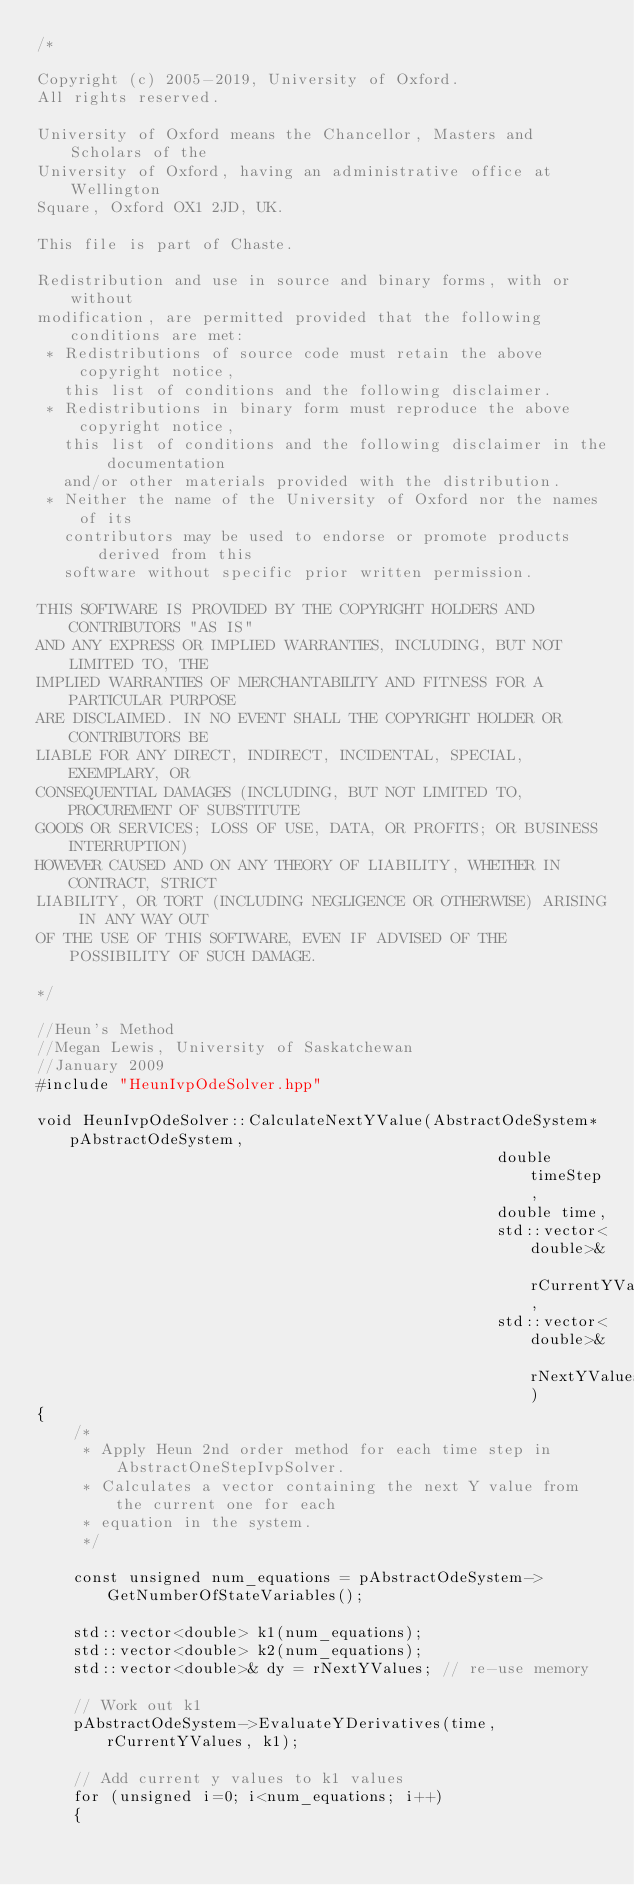<code> <loc_0><loc_0><loc_500><loc_500><_C++_>/*

Copyright (c) 2005-2019, University of Oxford.
All rights reserved.

University of Oxford means the Chancellor, Masters and Scholars of the
University of Oxford, having an administrative office at Wellington
Square, Oxford OX1 2JD, UK.

This file is part of Chaste.

Redistribution and use in source and binary forms, with or without
modification, are permitted provided that the following conditions are met:
 * Redistributions of source code must retain the above copyright notice,
   this list of conditions and the following disclaimer.
 * Redistributions in binary form must reproduce the above copyright notice,
   this list of conditions and the following disclaimer in the documentation
   and/or other materials provided with the distribution.
 * Neither the name of the University of Oxford nor the names of its
   contributors may be used to endorse or promote products derived from this
   software without specific prior written permission.

THIS SOFTWARE IS PROVIDED BY THE COPYRIGHT HOLDERS AND CONTRIBUTORS "AS IS"
AND ANY EXPRESS OR IMPLIED WARRANTIES, INCLUDING, BUT NOT LIMITED TO, THE
IMPLIED WARRANTIES OF MERCHANTABILITY AND FITNESS FOR A PARTICULAR PURPOSE
ARE DISCLAIMED. IN NO EVENT SHALL THE COPYRIGHT HOLDER OR CONTRIBUTORS BE
LIABLE FOR ANY DIRECT, INDIRECT, INCIDENTAL, SPECIAL, EXEMPLARY, OR
CONSEQUENTIAL DAMAGES (INCLUDING, BUT NOT LIMITED TO, PROCUREMENT OF SUBSTITUTE
GOODS OR SERVICES; LOSS OF USE, DATA, OR PROFITS; OR BUSINESS INTERRUPTION)
HOWEVER CAUSED AND ON ANY THEORY OF LIABILITY, WHETHER IN CONTRACT, STRICT
LIABILITY, OR TORT (INCLUDING NEGLIGENCE OR OTHERWISE) ARISING IN ANY WAY OUT
OF THE USE OF THIS SOFTWARE, EVEN IF ADVISED OF THE POSSIBILITY OF SUCH DAMAGE.

*/

//Heun's Method
//Megan Lewis, University of Saskatchewan
//January 2009
#include "HeunIvpOdeSolver.hpp"

void HeunIvpOdeSolver::CalculateNextYValue(AbstractOdeSystem* pAbstractOdeSystem,
                                                  double timeStep,
                                                  double time,
                                                  std::vector<double>& rCurrentYValues,
                                                  std::vector<double>& rNextYValues)
{
    /*
     * Apply Heun 2nd order method for each time step in AbstractOneStepIvpSolver.
     * Calculates a vector containing the next Y value from the current one for each
     * equation in the system.
     */

    const unsigned num_equations = pAbstractOdeSystem->GetNumberOfStateVariables();

    std::vector<double> k1(num_equations);
    std::vector<double> k2(num_equations);
    std::vector<double>& dy = rNextYValues; // re-use memory

    // Work out k1
    pAbstractOdeSystem->EvaluateYDerivatives(time, rCurrentYValues, k1);

    // Add current y values to k1 values
    for (unsigned i=0; i<num_equations; i++)
    {</code> 